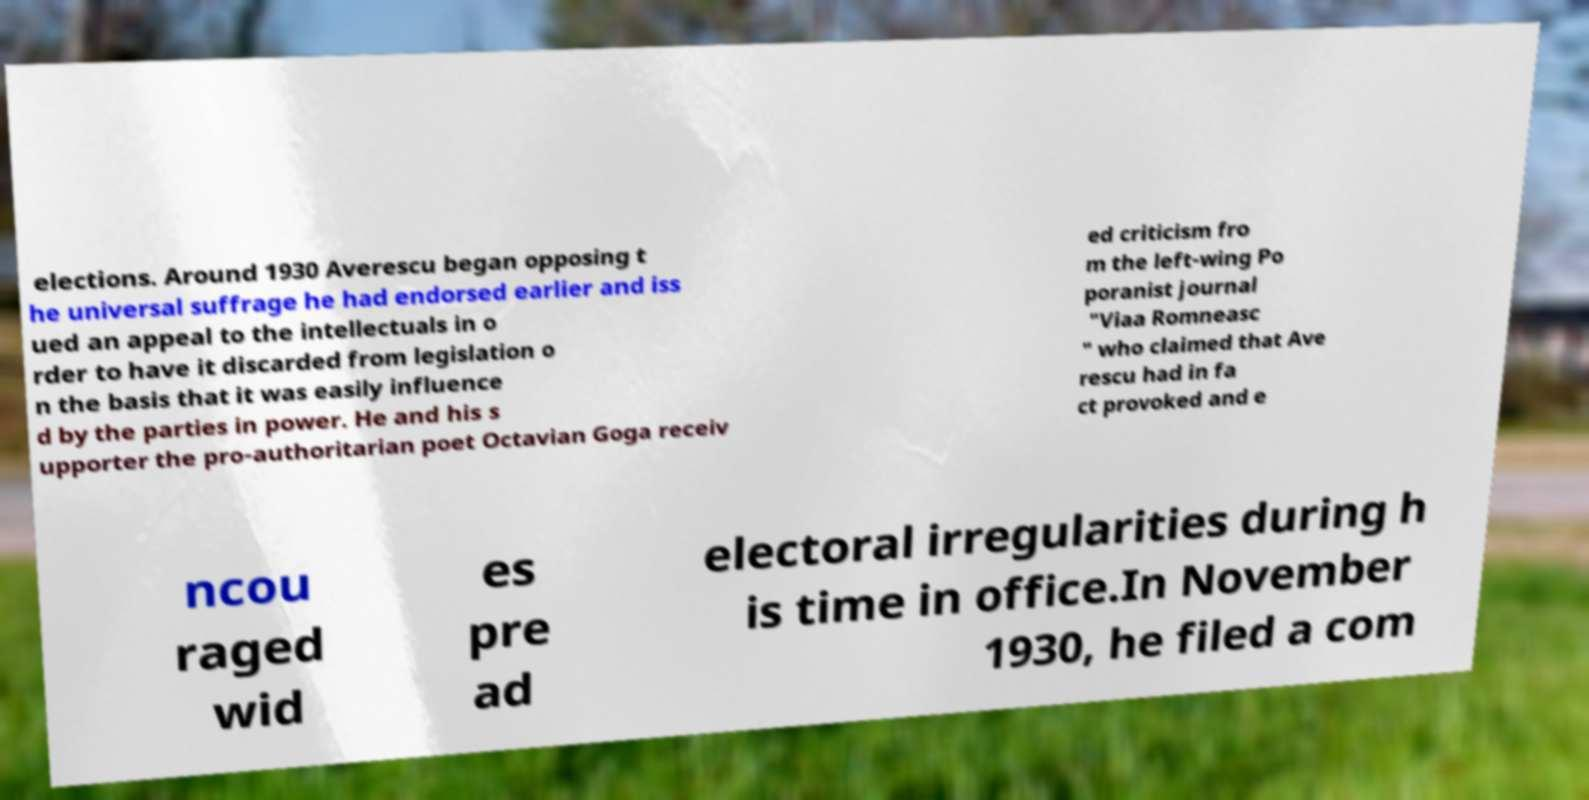Could you extract and type out the text from this image? elections. Around 1930 Averescu began opposing t he universal suffrage he had endorsed earlier and iss ued an appeal to the intellectuals in o rder to have it discarded from legislation o n the basis that it was easily influence d by the parties in power. He and his s upporter the pro-authoritarian poet Octavian Goga receiv ed criticism fro m the left-wing Po poranist journal "Viaa Romneasc " who claimed that Ave rescu had in fa ct provoked and e ncou raged wid es pre ad electoral irregularities during h is time in office.In November 1930, he filed a com 